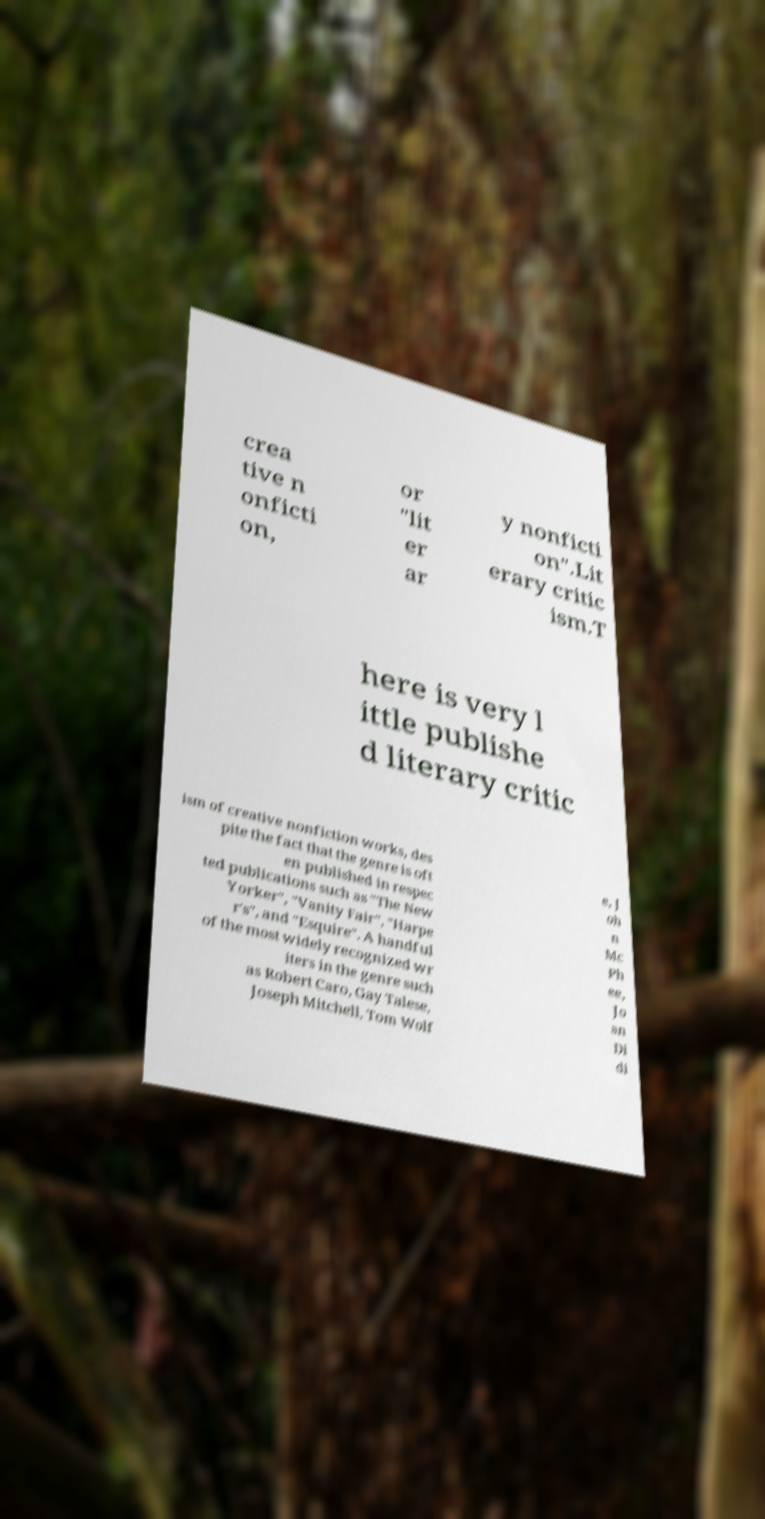Please identify and transcribe the text found in this image. crea tive n onficti on, or "lit er ar y nonficti on".Lit erary critic ism.T here is very l ittle publishe d literary critic ism of creative nonfiction works, des pite the fact that the genre is oft en published in respec ted publications such as "The New Yorker", "Vanity Fair", "Harpe r's", and "Esquire". A handful of the most widely recognized wr iters in the genre such as Robert Caro, Gay Talese, Joseph Mitchell, Tom Wolf e, J oh n Mc Ph ee, Jo an Di di 